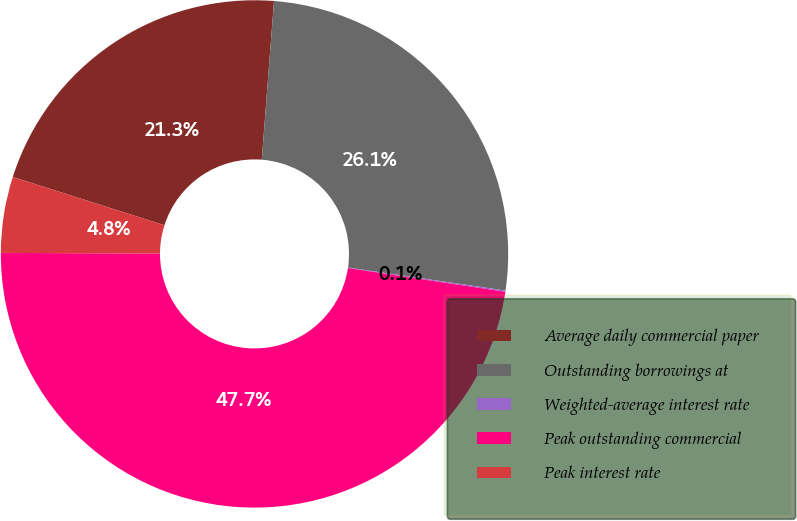Convert chart to OTSL. <chart><loc_0><loc_0><loc_500><loc_500><pie_chart><fcel>Average daily commercial paper<fcel>Outstanding borrowings at<fcel>Weighted-average interest rate<fcel>Peak outstanding commercial<fcel>Peak interest rate<nl><fcel>21.32%<fcel>26.08%<fcel>0.08%<fcel>47.68%<fcel>4.84%<nl></chart> 